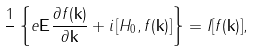Convert formula to latex. <formula><loc_0><loc_0><loc_500><loc_500>\frac { 1 } { } \left \{ e { \mathbf E } \frac { \partial f ( { \mathbf k } ) } { \partial { \mathbf k } } + i \left [ H _ { 0 } , f ( { \mathbf k } ) \right ] \right \} = I [ f ( { \mathbf k } ) ] ,</formula> 